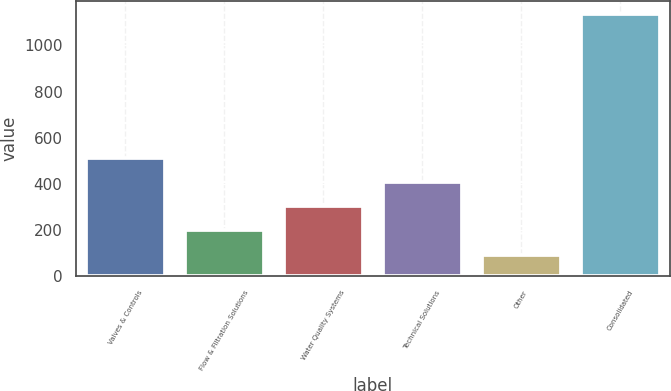Convert chart to OTSL. <chart><loc_0><loc_0><loc_500><loc_500><bar_chart><fcel>Valves & Controls<fcel>Flow & Filtration Solutions<fcel>Water Quality Systems<fcel>Technical Solutions<fcel>Other<fcel>Consolidated<nl><fcel>512.1<fcel>199.5<fcel>303.7<fcel>407.9<fcel>93.7<fcel>1135.7<nl></chart> 